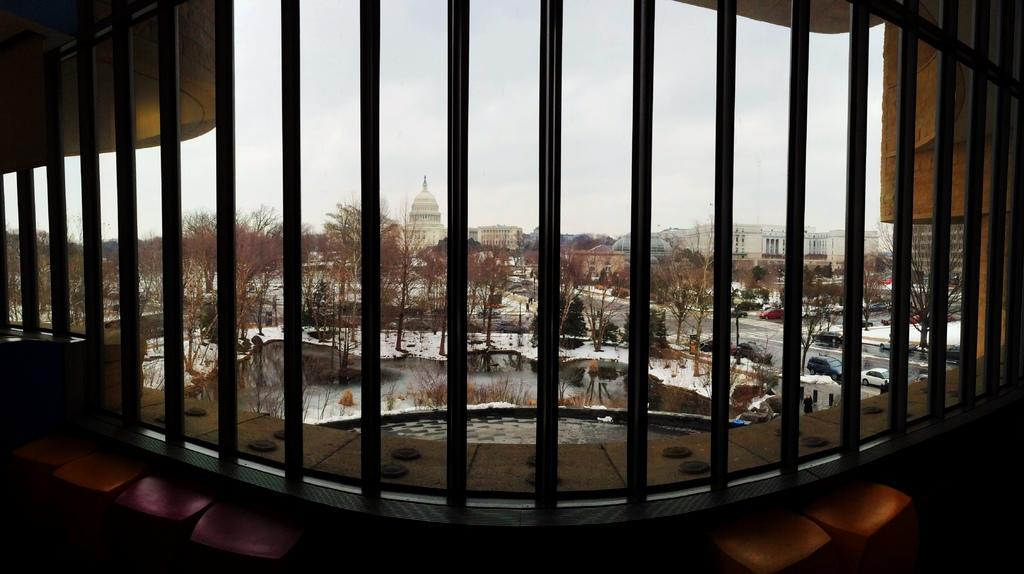What is the main subject of the image? The main subject of the image is grills. What can be seen through the grills? Trees, buildings, and vehicles on the road are visible through the grills. What type of pain is the person experiencing in the image? There is no person present in the image, and therefore no indication of pain. What is the aftermath of the game in the image? There is no game or any indication of an event in the image. 